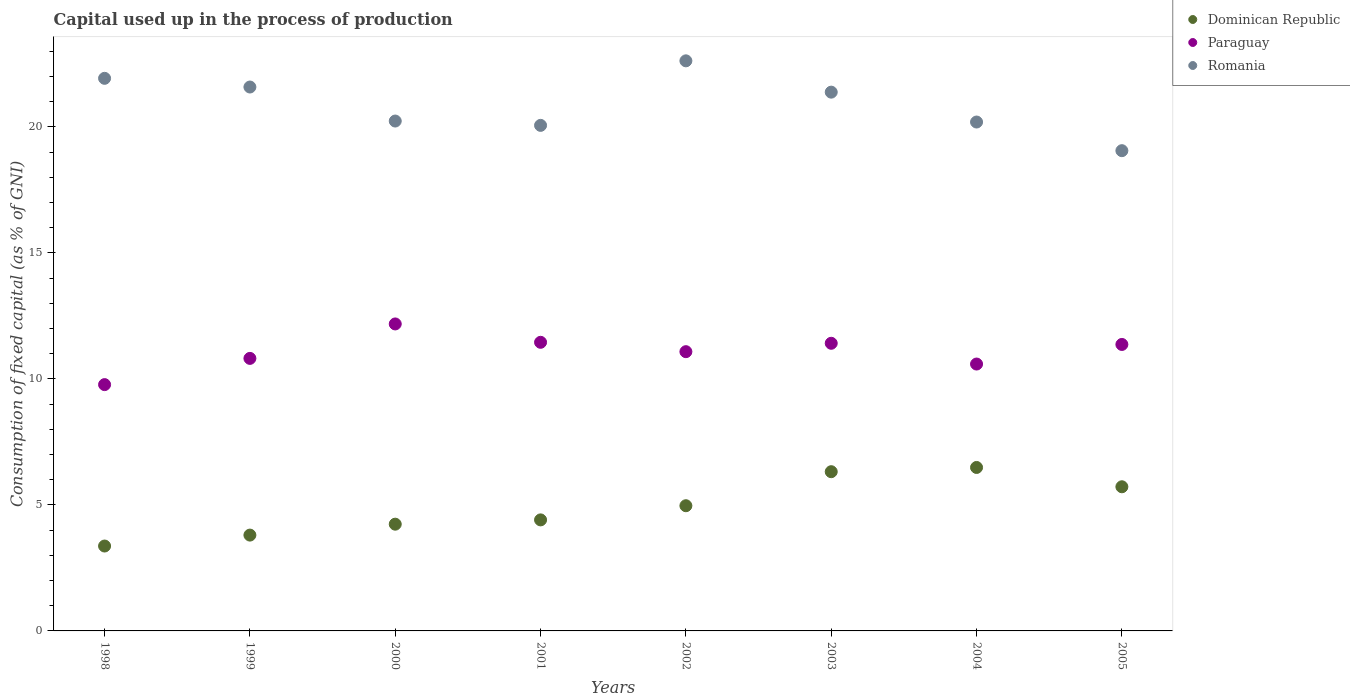How many different coloured dotlines are there?
Your response must be concise. 3. What is the capital used up in the process of production in Romania in 2003?
Your answer should be compact. 21.38. Across all years, what is the maximum capital used up in the process of production in Paraguay?
Offer a very short reply. 12.18. Across all years, what is the minimum capital used up in the process of production in Dominican Republic?
Provide a succinct answer. 3.37. In which year was the capital used up in the process of production in Paraguay maximum?
Make the answer very short. 2000. What is the total capital used up in the process of production in Paraguay in the graph?
Give a very brief answer. 88.68. What is the difference between the capital used up in the process of production in Romania in 2003 and that in 2005?
Offer a terse response. 2.32. What is the difference between the capital used up in the process of production in Romania in 2003 and the capital used up in the process of production in Paraguay in 2005?
Give a very brief answer. 10.01. What is the average capital used up in the process of production in Paraguay per year?
Your answer should be compact. 11.08. In the year 2002, what is the difference between the capital used up in the process of production in Romania and capital used up in the process of production in Dominican Republic?
Your answer should be compact. 17.65. In how many years, is the capital used up in the process of production in Dominican Republic greater than 2 %?
Make the answer very short. 8. What is the ratio of the capital used up in the process of production in Paraguay in 2003 to that in 2005?
Give a very brief answer. 1. Is the difference between the capital used up in the process of production in Romania in 2000 and 2004 greater than the difference between the capital used up in the process of production in Dominican Republic in 2000 and 2004?
Your answer should be compact. Yes. What is the difference between the highest and the second highest capital used up in the process of production in Dominican Republic?
Give a very brief answer. 0.17. What is the difference between the highest and the lowest capital used up in the process of production in Paraguay?
Your answer should be very brief. 2.41. In how many years, is the capital used up in the process of production in Dominican Republic greater than the average capital used up in the process of production in Dominican Republic taken over all years?
Keep it short and to the point. 4. Is the capital used up in the process of production in Dominican Republic strictly greater than the capital used up in the process of production in Romania over the years?
Offer a terse response. No. Is the capital used up in the process of production in Dominican Republic strictly less than the capital used up in the process of production in Romania over the years?
Offer a very short reply. Yes. How many years are there in the graph?
Keep it short and to the point. 8. What is the difference between two consecutive major ticks on the Y-axis?
Your answer should be compact. 5. Are the values on the major ticks of Y-axis written in scientific E-notation?
Keep it short and to the point. No. Does the graph contain grids?
Offer a terse response. No. Where does the legend appear in the graph?
Provide a short and direct response. Top right. What is the title of the graph?
Give a very brief answer. Capital used up in the process of production. What is the label or title of the X-axis?
Provide a short and direct response. Years. What is the label or title of the Y-axis?
Provide a succinct answer. Consumption of fixed capital (as % of GNI). What is the Consumption of fixed capital (as % of GNI) in Dominican Republic in 1998?
Offer a very short reply. 3.37. What is the Consumption of fixed capital (as % of GNI) in Paraguay in 1998?
Provide a succinct answer. 9.77. What is the Consumption of fixed capital (as % of GNI) in Romania in 1998?
Give a very brief answer. 21.93. What is the Consumption of fixed capital (as % of GNI) in Dominican Republic in 1999?
Keep it short and to the point. 3.8. What is the Consumption of fixed capital (as % of GNI) of Paraguay in 1999?
Your response must be concise. 10.81. What is the Consumption of fixed capital (as % of GNI) in Romania in 1999?
Your answer should be compact. 21.58. What is the Consumption of fixed capital (as % of GNI) of Dominican Republic in 2000?
Offer a terse response. 4.24. What is the Consumption of fixed capital (as % of GNI) of Paraguay in 2000?
Ensure brevity in your answer.  12.18. What is the Consumption of fixed capital (as % of GNI) in Romania in 2000?
Your answer should be very brief. 20.23. What is the Consumption of fixed capital (as % of GNI) in Dominican Republic in 2001?
Provide a short and direct response. 4.41. What is the Consumption of fixed capital (as % of GNI) of Paraguay in 2001?
Your answer should be compact. 11.45. What is the Consumption of fixed capital (as % of GNI) in Romania in 2001?
Offer a very short reply. 20.06. What is the Consumption of fixed capital (as % of GNI) of Dominican Republic in 2002?
Make the answer very short. 4.97. What is the Consumption of fixed capital (as % of GNI) of Paraguay in 2002?
Keep it short and to the point. 11.08. What is the Consumption of fixed capital (as % of GNI) in Romania in 2002?
Give a very brief answer. 22.62. What is the Consumption of fixed capital (as % of GNI) in Dominican Republic in 2003?
Your answer should be compact. 6.32. What is the Consumption of fixed capital (as % of GNI) in Paraguay in 2003?
Your answer should be very brief. 11.41. What is the Consumption of fixed capital (as % of GNI) of Romania in 2003?
Your answer should be compact. 21.38. What is the Consumption of fixed capital (as % of GNI) of Dominican Republic in 2004?
Ensure brevity in your answer.  6.49. What is the Consumption of fixed capital (as % of GNI) in Paraguay in 2004?
Your answer should be very brief. 10.59. What is the Consumption of fixed capital (as % of GNI) of Romania in 2004?
Offer a very short reply. 20.19. What is the Consumption of fixed capital (as % of GNI) in Dominican Republic in 2005?
Provide a succinct answer. 5.72. What is the Consumption of fixed capital (as % of GNI) of Paraguay in 2005?
Keep it short and to the point. 11.37. What is the Consumption of fixed capital (as % of GNI) of Romania in 2005?
Your answer should be very brief. 19.06. Across all years, what is the maximum Consumption of fixed capital (as % of GNI) in Dominican Republic?
Provide a succinct answer. 6.49. Across all years, what is the maximum Consumption of fixed capital (as % of GNI) in Paraguay?
Ensure brevity in your answer.  12.18. Across all years, what is the maximum Consumption of fixed capital (as % of GNI) in Romania?
Make the answer very short. 22.62. Across all years, what is the minimum Consumption of fixed capital (as % of GNI) of Dominican Republic?
Your answer should be compact. 3.37. Across all years, what is the minimum Consumption of fixed capital (as % of GNI) in Paraguay?
Offer a very short reply. 9.77. Across all years, what is the minimum Consumption of fixed capital (as % of GNI) in Romania?
Offer a very short reply. 19.06. What is the total Consumption of fixed capital (as % of GNI) in Dominican Republic in the graph?
Provide a short and direct response. 39.31. What is the total Consumption of fixed capital (as % of GNI) in Paraguay in the graph?
Your answer should be very brief. 88.68. What is the total Consumption of fixed capital (as % of GNI) of Romania in the graph?
Your answer should be very brief. 167.06. What is the difference between the Consumption of fixed capital (as % of GNI) in Dominican Republic in 1998 and that in 1999?
Offer a terse response. -0.43. What is the difference between the Consumption of fixed capital (as % of GNI) in Paraguay in 1998 and that in 1999?
Provide a succinct answer. -1.04. What is the difference between the Consumption of fixed capital (as % of GNI) of Romania in 1998 and that in 1999?
Provide a short and direct response. 0.35. What is the difference between the Consumption of fixed capital (as % of GNI) of Dominican Republic in 1998 and that in 2000?
Keep it short and to the point. -0.87. What is the difference between the Consumption of fixed capital (as % of GNI) of Paraguay in 1998 and that in 2000?
Offer a very short reply. -2.41. What is the difference between the Consumption of fixed capital (as % of GNI) in Romania in 1998 and that in 2000?
Provide a short and direct response. 1.7. What is the difference between the Consumption of fixed capital (as % of GNI) in Dominican Republic in 1998 and that in 2001?
Your response must be concise. -1.04. What is the difference between the Consumption of fixed capital (as % of GNI) in Paraguay in 1998 and that in 2001?
Offer a terse response. -1.68. What is the difference between the Consumption of fixed capital (as % of GNI) in Romania in 1998 and that in 2001?
Ensure brevity in your answer.  1.87. What is the difference between the Consumption of fixed capital (as % of GNI) in Dominican Republic in 1998 and that in 2002?
Offer a very short reply. -1.6. What is the difference between the Consumption of fixed capital (as % of GNI) of Paraguay in 1998 and that in 2002?
Offer a terse response. -1.31. What is the difference between the Consumption of fixed capital (as % of GNI) in Romania in 1998 and that in 2002?
Give a very brief answer. -0.69. What is the difference between the Consumption of fixed capital (as % of GNI) of Dominican Republic in 1998 and that in 2003?
Make the answer very short. -2.95. What is the difference between the Consumption of fixed capital (as % of GNI) in Paraguay in 1998 and that in 2003?
Offer a terse response. -1.64. What is the difference between the Consumption of fixed capital (as % of GNI) in Romania in 1998 and that in 2003?
Give a very brief answer. 0.55. What is the difference between the Consumption of fixed capital (as % of GNI) of Dominican Republic in 1998 and that in 2004?
Give a very brief answer. -3.12. What is the difference between the Consumption of fixed capital (as % of GNI) of Paraguay in 1998 and that in 2004?
Your answer should be very brief. -0.82. What is the difference between the Consumption of fixed capital (as % of GNI) in Romania in 1998 and that in 2004?
Your response must be concise. 1.73. What is the difference between the Consumption of fixed capital (as % of GNI) in Dominican Republic in 1998 and that in 2005?
Make the answer very short. -2.35. What is the difference between the Consumption of fixed capital (as % of GNI) in Paraguay in 1998 and that in 2005?
Ensure brevity in your answer.  -1.59. What is the difference between the Consumption of fixed capital (as % of GNI) of Romania in 1998 and that in 2005?
Your answer should be compact. 2.87. What is the difference between the Consumption of fixed capital (as % of GNI) in Dominican Republic in 1999 and that in 2000?
Offer a very short reply. -0.43. What is the difference between the Consumption of fixed capital (as % of GNI) of Paraguay in 1999 and that in 2000?
Keep it short and to the point. -1.37. What is the difference between the Consumption of fixed capital (as % of GNI) of Romania in 1999 and that in 2000?
Ensure brevity in your answer.  1.35. What is the difference between the Consumption of fixed capital (as % of GNI) in Dominican Republic in 1999 and that in 2001?
Your response must be concise. -0.6. What is the difference between the Consumption of fixed capital (as % of GNI) of Paraguay in 1999 and that in 2001?
Offer a very short reply. -0.64. What is the difference between the Consumption of fixed capital (as % of GNI) in Romania in 1999 and that in 2001?
Offer a terse response. 1.52. What is the difference between the Consumption of fixed capital (as % of GNI) of Dominican Republic in 1999 and that in 2002?
Your answer should be very brief. -1.17. What is the difference between the Consumption of fixed capital (as % of GNI) in Paraguay in 1999 and that in 2002?
Provide a short and direct response. -0.27. What is the difference between the Consumption of fixed capital (as % of GNI) of Romania in 1999 and that in 2002?
Provide a short and direct response. -1.04. What is the difference between the Consumption of fixed capital (as % of GNI) of Dominican Republic in 1999 and that in 2003?
Keep it short and to the point. -2.52. What is the difference between the Consumption of fixed capital (as % of GNI) of Paraguay in 1999 and that in 2003?
Your answer should be very brief. -0.6. What is the difference between the Consumption of fixed capital (as % of GNI) in Romania in 1999 and that in 2003?
Make the answer very short. 0.2. What is the difference between the Consumption of fixed capital (as % of GNI) in Dominican Republic in 1999 and that in 2004?
Your response must be concise. -2.68. What is the difference between the Consumption of fixed capital (as % of GNI) in Paraguay in 1999 and that in 2004?
Offer a very short reply. 0.22. What is the difference between the Consumption of fixed capital (as % of GNI) of Romania in 1999 and that in 2004?
Ensure brevity in your answer.  1.39. What is the difference between the Consumption of fixed capital (as % of GNI) in Dominican Republic in 1999 and that in 2005?
Your answer should be very brief. -1.92. What is the difference between the Consumption of fixed capital (as % of GNI) in Paraguay in 1999 and that in 2005?
Provide a short and direct response. -0.55. What is the difference between the Consumption of fixed capital (as % of GNI) in Romania in 1999 and that in 2005?
Your answer should be very brief. 2.53. What is the difference between the Consumption of fixed capital (as % of GNI) of Dominican Republic in 2000 and that in 2001?
Provide a short and direct response. -0.17. What is the difference between the Consumption of fixed capital (as % of GNI) of Paraguay in 2000 and that in 2001?
Your answer should be very brief. 0.73. What is the difference between the Consumption of fixed capital (as % of GNI) of Romania in 2000 and that in 2001?
Provide a succinct answer. 0.17. What is the difference between the Consumption of fixed capital (as % of GNI) in Dominican Republic in 2000 and that in 2002?
Keep it short and to the point. -0.73. What is the difference between the Consumption of fixed capital (as % of GNI) in Paraguay in 2000 and that in 2002?
Your answer should be very brief. 1.1. What is the difference between the Consumption of fixed capital (as % of GNI) of Romania in 2000 and that in 2002?
Offer a very short reply. -2.39. What is the difference between the Consumption of fixed capital (as % of GNI) in Dominican Republic in 2000 and that in 2003?
Your response must be concise. -2.08. What is the difference between the Consumption of fixed capital (as % of GNI) of Paraguay in 2000 and that in 2003?
Your response must be concise. 0.77. What is the difference between the Consumption of fixed capital (as % of GNI) of Romania in 2000 and that in 2003?
Your response must be concise. -1.15. What is the difference between the Consumption of fixed capital (as % of GNI) in Dominican Republic in 2000 and that in 2004?
Ensure brevity in your answer.  -2.25. What is the difference between the Consumption of fixed capital (as % of GNI) in Paraguay in 2000 and that in 2004?
Your answer should be compact. 1.59. What is the difference between the Consumption of fixed capital (as % of GNI) of Romania in 2000 and that in 2004?
Provide a succinct answer. 0.04. What is the difference between the Consumption of fixed capital (as % of GNI) of Dominican Republic in 2000 and that in 2005?
Your response must be concise. -1.48. What is the difference between the Consumption of fixed capital (as % of GNI) of Paraguay in 2000 and that in 2005?
Offer a terse response. 0.81. What is the difference between the Consumption of fixed capital (as % of GNI) in Romania in 2000 and that in 2005?
Offer a very short reply. 1.18. What is the difference between the Consumption of fixed capital (as % of GNI) in Dominican Republic in 2001 and that in 2002?
Offer a very short reply. -0.56. What is the difference between the Consumption of fixed capital (as % of GNI) in Paraguay in 2001 and that in 2002?
Give a very brief answer. 0.37. What is the difference between the Consumption of fixed capital (as % of GNI) of Romania in 2001 and that in 2002?
Your answer should be compact. -2.56. What is the difference between the Consumption of fixed capital (as % of GNI) in Dominican Republic in 2001 and that in 2003?
Make the answer very short. -1.91. What is the difference between the Consumption of fixed capital (as % of GNI) in Paraguay in 2001 and that in 2003?
Offer a very short reply. 0.04. What is the difference between the Consumption of fixed capital (as % of GNI) in Romania in 2001 and that in 2003?
Give a very brief answer. -1.32. What is the difference between the Consumption of fixed capital (as % of GNI) in Dominican Republic in 2001 and that in 2004?
Offer a very short reply. -2.08. What is the difference between the Consumption of fixed capital (as % of GNI) of Paraguay in 2001 and that in 2004?
Make the answer very short. 0.86. What is the difference between the Consumption of fixed capital (as % of GNI) of Romania in 2001 and that in 2004?
Your answer should be compact. -0.13. What is the difference between the Consumption of fixed capital (as % of GNI) of Dominican Republic in 2001 and that in 2005?
Give a very brief answer. -1.31. What is the difference between the Consumption of fixed capital (as % of GNI) of Paraguay in 2001 and that in 2005?
Keep it short and to the point. 0.09. What is the difference between the Consumption of fixed capital (as % of GNI) of Romania in 2001 and that in 2005?
Your response must be concise. 1. What is the difference between the Consumption of fixed capital (as % of GNI) of Dominican Republic in 2002 and that in 2003?
Ensure brevity in your answer.  -1.35. What is the difference between the Consumption of fixed capital (as % of GNI) of Paraguay in 2002 and that in 2003?
Keep it short and to the point. -0.33. What is the difference between the Consumption of fixed capital (as % of GNI) in Romania in 2002 and that in 2003?
Keep it short and to the point. 1.24. What is the difference between the Consumption of fixed capital (as % of GNI) in Dominican Republic in 2002 and that in 2004?
Keep it short and to the point. -1.52. What is the difference between the Consumption of fixed capital (as % of GNI) in Paraguay in 2002 and that in 2004?
Your answer should be compact. 0.49. What is the difference between the Consumption of fixed capital (as % of GNI) in Romania in 2002 and that in 2004?
Give a very brief answer. 2.43. What is the difference between the Consumption of fixed capital (as % of GNI) in Dominican Republic in 2002 and that in 2005?
Offer a terse response. -0.75. What is the difference between the Consumption of fixed capital (as % of GNI) in Paraguay in 2002 and that in 2005?
Give a very brief answer. -0.29. What is the difference between the Consumption of fixed capital (as % of GNI) of Romania in 2002 and that in 2005?
Keep it short and to the point. 3.56. What is the difference between the Consumption of fixed capital (as % of GNI) in Dominican Republic in 2003 and that in 2004?
Make the answer very short. -0.17. What is the difference between the Consumption of fixed capital (as % of GNI) in Paraguay in 2003 and that in 2004?
Offer a terse response. 0.82. What is the difference between the Consumption of fixed capital (as % of GNI) in Romania in 2003 and that in 2004?
Make the answer very short. 1.19. What is the difference between the Consumption of fixed capital (as % of GNI) in Dominican Republic in 2003 and that in 2005?
Your answer should be compact. 0.6. What is the difference between the Consumption of fixed capital (as % of GNI) of Paraguay in 2003 and that in 2005?
Ensure brevity in your answer.  0.05. What is the difference between the Consumption of fixed capital (as % of GNI) in Romania in 2003 and that in 2005?
Your answer should be very brief. 2.32. What is the difference between the Consumption of fixed capital (as % of GNI) of Dominican Republic in 2004 and that in 2005?
Your answer should be compact. 0.77. What is the difference between the Consumption of fixed capital (as % of GNI) in Paraguay in 2004 and that in 2005?
Make the answer very short. -0.78. What is the difference between the Consumption of fixed capital (as % of GNI) in Romania in 2004 and that in 2005?
Make the answer very short. 1.14. What is the difference between the Consumption of fixed capital (as % of GNI) of Dominican Republic in 1998 and the Consumption of fixed capital (as % of GNI) of Paraguay in 1999?
Give a very brief answer. -7.45. What is the difference between the Consumption of fixed capital (as % of GNI) in Dominican Republic in 1998 and the Consumption of fixed capital (as % of GNI) in Romania in 1999?
Your answer should be compact. -18.21. What is the difference between the Consumption of fixed capital (as % of GNI) of Paraguay in 1998 and the Consumption of fixed capital (as % of GNI) of Romania in 1999?
Ensure brevity in your answer.  -11.81. What is the difference between the Consumption of fixed capital (as % of GNI) in Dominican Republic in 1998 and the Consumption of fixed capital (as % of GNI) in Paraguay in 2000?
Give a very brief answer. -8.81. What is the difference between the Consumption of fixed capital (as % of GNI) of Dominican Republic in 1998 and the Consumption of fixed capital (as % of GNI) of Romania in 2000?
Make the answer very short. -16.86. What is the difference between the Consumption of fixed capital (as % of GNI) in Paraguay in 1998 and the Consumption of fixed capital (as % of GNI) in Romania in 2000?
Provide a short and direct response. -10.46. What is the difference between the Consumption of fixed capital (as % of GNI) of Dominican Republic in 1998 and the Consumption of fixed capital (as % of GNI) of Paraguay in 2001?
Offer a very short reply. -8.08. What is the difference between the Consumption of fixed capital (as % of GNI) of Dominican Republic in 1998 and the Consumption of fixed capital (as % of GNI) of Romania in 2001?
Make the answer very short. -16.69. What is the difference between the Consumption of fixed capital (as % of GNI) of Paraguay in 1998 and the Consumption of fixed capital (as % of GNI) of Romania in 2001?
Provide a short and direct response. -10.29. What is the difference between the Consumption of fixed capital (as % of GNI) in Dominican Republic in 1998 and the Consumption of fixed capital (as % of GNI) in Paraguay in 2002?
Provide a succinct answer. -7.71. What is the difference between the Consumption of fixed capital (as % of GNI) of Dominican Republic in 1998 and the Consumption of fixed capital (as % of GNI) of Romania in 2002?
Your answer should be very brief. -19.25. What is the difference between the Consumption of fixed capital (as % of GNI) in Paraguay in 1998 and the Consumption of fixed capital (as % of GNI) in Romania in 2002?
Your response must be concise. -12.85. What is the difference between the Consumption of fixed capital (as % of GNI) in Dominican Republic in 1998 and the Consumption of fixed capital (as % of GNI) in Paraguay in 2003?
Your response must be concise. -8.05. What is the difference between the Consumption of fixed capital (as % of GNI) of Dominican Republic in 1998 and the Consumption of fixed capital (as % of GNI) of Romania in 2003?
Your response must be concise. -18.01. What is the difference between the Consumption of fixed capital (as % of GNI) of Paraguay in 1998 and the Consumption of fixed capital (as % of GNI) of Romania in 2003?
Your response must be concise. -11.61. What is the difference between the Consumption of fixed capital (as % of GNI) in Dominican Republic in 1998 and the Consumption of fixed capital (as % of GNI) in Paraguay in 2004?
Make the answer very short. -7.22. What is the difference between the Consumption of fixed capital (as % of GNI) of Dominican Republic in 1998 and the Consumption of fixed capital (as % of GNI) of Romania in 2004?
Ensure brevity in your answer.  -16.83. What is the difference between the Consumption of fixed capital (as % of GNI) of Paraguay in 1998 and the Consumption of fixed capital (as % of GNI) of Romania in 2004?
Make the answer very short. -10.42. What is the difference between the Consumption of fixed capital (as % of GNI) in Dominican Republic in 1998 and the Consumption of fixed capital (as % of GNI) in Paraguay in 2005?
Make the answer very short. -8. What is the difference between the Consumption of fixed capital (as % of GNI) in Dominican Republic in 1998 and the Consumption of fixed capital (as % of GNI) in Romania in 2005?
Provide a succinct answer. -15.69. What is the difference between the Consumption of fixed capital (as % of GNI) of Paraguay in 1998 and the Consumption of fixed capital (as % of GNI) of Romania in 2005?
Your answer should be compact. -9.28. What is the difference between the Consumption of fixed capital (as % of GNI) of Dominican Republic in 1999 and the Consumption of fixed capital (as % of GNI) of Paraguay in 2000?
Provide a succinct answer. -8.38. What is the difference between the Consumption of fixed capital (as % of GNI) of Dominican Republic in 1999 and the Consumption of fixed capital (as % of GNI) of Romania in 2000?
Make the answer very short. -16.43. What is the difference between the Consumption of fixed capital (as % of GNI) in Paraguay in 1999 and the Consumption of fixed capital (as % of GNI) in Romania in 2000?
Keep it short and to the point. -9.42. What is the difference between the Consumption of fixed capital (as % of GNI) in Dominican Republic in 1999 and the Consumption of fixed capital (as % of GNI) in Paraguay in 2001?
Provide a short and direct response. -7.65. What is the difference between the Consumption of fixed capital (as % of GNI) of Dominican Republic in 1999 and the Consumption of fixed capital (as % of GNI) of Romania in 2001?
Make the answer very short. -16.26. What is the difference between the Consumption of fixed capital (as % of GNI) in Paraguay in 1999 and the Consumption of fixed capital (as % of GNI) in Romania in 2001?
Offer a terse response. -9.25. What is the difference between the Consumption of fixed capital (as % of GNI) in Dominican Republic in 1999 and the Consumption of fixed capital (as % of GNI) in Paraguay in 2002?
Your answer should be very brief. -7.28. What is the difference between the Consumption of fixed capital (as % of GNI) in Dominican Republic in 1999 and the Consumption of fixed capital (as % of GNI) in Romania in 2002?
Make the answer very short. -18.82. What is the difference between the Consumption of fixed capital (as % of GNI) in Paraguay in 1999 and the Consumption of fixed capital (as % of GNI) in Romania in 2002?
Provide a succinct answer. -11.81. What is the difference between the Consumption of fixed capital (as % of GNI) in Dominican Republic in 1999 and the Consumption of fixed capital (as % of GNI) in Paraguay in 2003?
Your response must be concise. -7.61. What is the difference between the Consumption of fixed capital (as % of GNI) of Dominican Republic in 1999 and the Consumption of fixed capital (as % of GNI) of Romania in 2003?
Keep it short and to the point. -17.58. What is the difference between the Consumption of fixed capital (as % of GNI) in Paraguay in 1999 and the Consumption of fixed capital (as % of GNI) in Romania in 2003?
Offer a terse response. -10.57. What is the difference between the Consumption of fixed capital (as % of GNI) in Dominican Republic in 1999 and the Consumption of fixed capital (as % of GNI) in Paraguay in 2004?
Your answer should be compact. -6.79. What is the difference between the Consumption of fixed capital (as % of GNI) of Dominican Republic in 1999 and the Consumption of fixed capital (as % of GNI) of Romania in 2004?
Offer a terse response. -16.39. What is the difference between the Consumption of fixed capital (as % of GNI) of Paraguay in 1999 and the Consumption of fixed capital (as % of GNI) of Romania in 2004?
Ensure brevity in your answer.  -9.38. What is the difference between the Consumption of fixed capital (as % of GNI) in Dominican Republic in 1999 and the Consumption of fixed capital (as % of GNI) in Paraguay in 2005?
Your response must be concise. -7.57. What is the difference between the Consumption of fixed capital (as % of GNI) of Dominican Republic in 1999 and the Consumption of fixed capital (as % of GNI) of Romania in 2005?
Offer a terse response. -15.26. What is the difference between the Consumption of fixed capital (as % of GNI) of Paraguay in 1999 and the Consumption of fixed capital (as % of GNI) of Romania in 2005?
Your response must be concise. -8.24. What is the difference between the Consumption of fixed capital (as % of GNI) in Dominican Republic in 2000 and the Consumption of fixed capital (as % of GNI) in Paraguay in 2001?
Your answer should be very brief. -7.22. What is the difference between the Consumption of fixed capital (as % of GNI) in Dominican Republic in 2000 and the Consumption of fixed capital (as % of GNI) in Romania in 2001?
Provide a short and direct response. -15.83. What is the difference between the Consumption of fixed capital (as % of GNI) in Paraguay in 2000 and the Consumption of fixed capital (as % of GNI) in Romania in 2001?
Your response must be concise. -7.88. What is the difference between the Consumption of fixed capital (as % of GNI) of Dominican Republic in 2000 and the Consumption of fixed capital (as % of GNI) of Paraguay in 2002?
Keep it short and to the point. -6.85. What is the difference between the Consumption of fixed capital (as % of GNI) in Dominican Republic in 2000 and the Consumption of fixed capital (as % of GNI) in Romania in 2002?
Keep it short and to the point. -18.39. What is the difference between the Consumption of fixed capital (as % of GNI) of Paraguay in 2000 and the Consumption of fixed capital (as % of GNI) of Romania in 2002?
Your answer should be compact. -10.44. What is the difference between the Consumption of fixed capital (as % of GNI) in Dominican Republic in 2000 and the Consumption of fixed capital (as % of GNI) in Paraguay in 2003?
Ensure brevity in your answer.  -7.18. What is the difference between the Consumption of fixed capital (as % of GNI) in Dominican Republic in 2000 and the Consumption of fixed capital (as % of GNI) in Romania in 2003?
Make the answer very short. -17.14. What is the difference between the Consumption of fixed capital (as % of GNI) in Paraguay in 2000 and the Consumption of fixed capital (as % of GNI) in Romania in 2003?
Offer a very short reply. -9.2. What is the difference between the Consumption of fixed capital (as % of GNI) in Dominican Republic in 2000 and the Consumption of fixed capital (as % of GNI) in Paraguay in 2004?
Provide a succinct answer. -6.35. What is the difference between the Consumption of fixed capital (as % of GNI) of Dominican Republic in 2000 and the Consumption of fixed capital (as % of GNI) of Romania in 2004?
Your answer should be very brief. -15.96. What is the difference between the Consumption of fixed capital (as % of GNI) of Paraguay in 2000 and the Consumption of fixed capital (as % of GNI) of Romania in 2004?
Provide a short and direct response. -8.01. What is the difference between the Consumption of fixed capital (as % of GNI) of Dominican Republic in 2000 and the Consumption of fixed capital (as % of GNI) of Paraguay in 2005?
Ensure brevity in your answer.  -7.13. What is the difference between the Consumption of fixed capital (as % of GNI) in Dominican Republic in 2000 and the Consumption of fixed capital (as % of GNI) in Romania in 2005?
Your answer should be compact. -14.82. What is the difference between the Consumption of fixed capital (as % of GNI) of Paraguay in 2000 and the Consumption of fixed capital (as % of GNI) of Romania in 2005?
Your response must be concise. -6.88. What is the difference between the Consumption of fixed capital (as % of GNI) in Dominican Republic in 2001 and the Consumption of fixed capital (as % of GNI) in Paraguay in 2002?
Your answer should be very brief. -6.68. What is the difference between the Consumption of fixed capital (as % of GNI) of Dominican Republic in 2001 and the Consumption of fixed capital (as % of GNI) of Romania in 2002?
Offer a terse response. -18.22. What is the difference between the Consumption of fixed capital (as % of GNI) in Paraguay in 2001 and the Consumption of fixed capital (as % of GNI) in Romania in 2002?
Ensure brevity in your answer.  -11.17. What is the difference between the Consumption of fixed capital (as % of GNI) in Dominican Republic in 2001 and the Consumption of fixed capital (as % of GNI) in Paraguay in 2003?
Make the answer very short. -7.01. What is the difference between the Consumption of fixed capital (as % of GNI) in Dominican Republic in 2001 and the Consumption of fixed capital (as % of GNI) in Romania in 2003?
Offer a terse response. -16.97. What is the difference between the Consumption of fixed capital (as % of GNI) of Paraguay in 2001 and the Consumption of fixed capital (as % of GNI) of Romania in 2003?
Keep it short and to the point. -9.93. What is the difference between the Consumption of fixed capital (as % of GNI) of Dominican Republic in 2001 and the Consumption of fixed capital (as % of GNI) of Paraguay in 2004?
Ensure brevity in your answer.  -6.18. What is the difference between the Consumption of fixed capital (as % of GNI) in Dominican Republic in 2001 and the Consumption of fixed capital (as % of GNI) in Romania in 2004?
Provide a succinct answer. -15.79. What is the difference between the Consumption of fixed capital (as % of GNI) in Paraguay in 2001 and the Consumption of fixed capital (as % of GNI) in Romania in 2004?
Your answer should be compact. -8.74. What is the difference between the Consumption of fixed capital (as % of GNI) of Dominican Republic in 2001 and the Consumption of fixed capital (as % of GNI) of Paraguay in 2005?
Offer a terse response. -6.96. What is the difference between the Consumption of fixed capital (as % of GNI) in Dominican Republic in 2001 and the Consumption of fixed capital (as % of GNI) in Romania in 2005?
Your response must be concise. -14.65. What is the difference between the Consumption of fixed capital (as % of GNI) of Paraguay in 2001 and the Consumption of fixed capital (as % of GNI) of Romania in 2005?
Make the answer very short. -7.6. What is the difference between the Consumption of fixed capital (as % of GNI) in Dominican Republic in 2002 and the Consumption of fixed capital (as % of GNI) in Paraguay in 2003?
Provide a short and direct response. -6.45. What is the difference between the Consumption of fixed capital (as % of GNI) of Dominican Republic in 2002 and the Consumption of fixed capital (as % of GNI) of Romania in 2003?
Provide a succinct answer. -16.41. What is the difference between the Consumption of fixed capital (as % of GNI) of Paraguay in 2002 and the Consumption of fixed capital (as % of GNI) of Romania in 2003?
Keep it short and to the point. -10.3. What is the difference between the Consumption of fixed capital (as % of GNI) in Dominican Republic in 2002 and the Consumption of fixed capital (as % of GNI) in Paraguay in 2004?
Your answer should be compact. -5.62. What is the difference between the Consumption of fixed capital (as % of GNI) in Dominican Republic in 2002 and the Consumption of fixed capital (as % of GNI) in Romania in 2004?
Your answer should be very brief. -15.23. What is the difference between the Consumption of fixed capital (as % of GNI) in Paraguay in 2002 and the Consumption of fixed capital (as % of GNI) in Romania in 2004?
Your answer should be very brief. -9.11. What is the difference between the Consumption of fixed capital (as % of GNI) of Dominican Republic in 2002 and the Consumption of fixed capital (as % of GNI) of Paraguay in 2005?
Provide a short and direct response. -6.4. What is the difference between the Consumption of fixed capital (as % of GNI) of Dominican Republic in 2002 and the Consumption of fixed capital (as % of GNI) of Romania in 2005?
Your answer should be compact. -14.09. What is the difference between the Consumption of fixed capital (as % of GNI) in Paraguay in 2002 and the Consumption of fixed capital (as % of GNI) in Romania in 2005?
Give a very brief answer. -7.98. What is the difference between the Consumption of fixed capital (as % of GNI) in Dominican Republic in 2003 and the Consumption of fixed capital (as % of GNI) in Paraguay in 2004?
Ensure brevity in your answer.  -4.27. What is the difference between the Consumption of fixed capital (as % of GNI) of Dominican Republic in 2003 and the Consumption of fixed capital (as % of GNI) of Romania in 2004?
Your answer should be compact. -13.88. What is the difference between the Consumption of fixed capital (as % of GNI) of Paraguay in 2003 and the Consumption of fixed capital (as % of GNI) of Romania in 2004?
Your answer should be compact. -8.78. What is the difference between the Consumption of fixed capital (as % of GNI) of Dominican Republic in 2003 and the Consumption of fixed capital (as % of GNI) of Paraguay in 2005?
Provide a short and direct response. -5.05. What is the difference between the Consumption of fixed capital (as % of GNI) of Dominican Republic in 2003 and the Consumption of fixed capital (as % of GNI) of Romania in 2005?
Keep it short and to the point. -12.74. What is the difference between the Consumption of fixed capital (as % of GNI) of Paraguay in 2003 and the Consumption of fixed capital (as % of GNI) of Romania in 2005?
Provide a succinct answer. -7.64. What is the difference between the Consumption of fixed capital (as % of GNI) in Dominican Republic in 2004 and the Consumption of fixed capital (as % of GNI) in Paraguay in 2005?
Provide a succinct answer. -4.88. What is the difference between the Consumption of fixed capital (as % of GNI) of Dominican Republic in 2004 and the Consumption of fixed capital (as % of GNI) of Romania in 2005?
Keep it short and to the point. -12.57. What is the difference between the Consumption of fixed capital (as % of GNI) of Paraguay in 2004 and the Consumption of fixed capital (as % of GNI) of Romania in 2005?
Offer a very short reply. -8.47. What is the average Consumption of fixed capital (as % of GNI) in Dominican Republic per year?
Your answer should be compact. 4.91. What is the average Consumption of fixed capital (as % of GNI) of Paraguay per year?
Your answer should be very brief. 11.08. What is the average Consumption of fixed capital (as % of GNI) of Romania per year?
Your answer should be compact. 20.88. In the year 1998, what is the difference between the Consumption of fixed capital (as % of GNI) in Dominican Republic and Consumption of fixed capital (as % of GNI) in Paraguay?
Your answer should be compact. -6.41. In the year 1998, what is the difference between the Consumption of fixed capital (as % of GNI) of Dominican Republic and Consumption of fixed capital (as % of GNI) of Romania?
Offer a very short reply. -18.56. In the year 1998, what is the difference between the Consumption of fixed capital (as % of GNI) in Paraguay and Consumption of fixed capital (as % of GNI) in Romania?
Your answer should be compact. -12.15. In the year 1999, what is the difference between the Consumption of fixed capital (as % of GNI) of Dominican Republic and Consumption of fixed capital (as % of GNI) of Paraguay?
Make the answer very short. -7.01. In the year 1999, what is the difference between the Consumption of fixed capital (as % of GNI) in Dominican Republic and Consumption of fixed capital (as % of GNI) in Romania?
Your answer should be compact. -17.78. In the year 1999, what is the difference between the Consumption of fixed capital (as % of GNI) of Paraguay and Consumption of fixed capital (as % of GNI) of Romania?
Offer a very short reply. -10.77. In the year 2000, what is the difference between the Consumption of fixed capital (as % of GNI) of Dominican Republic and Consumption of fixed capital (as % of GNI) of Paraguay?
Give a very brief answer. -7.95. In the year 2000, what is the difference between the Consumption of fixed capital (as % of GNI) in Dominican Republic and Consumption of fixed capital (as % of GNI) in Romania?
Provide a succinct answer. -16. In the year 2000, what is the difference between the Consumption of fixed capital (as % of GNI) in Paraguay and Consumption of fixed capital (as % of GNI) in Romania?
Your answer should be very brief. -8.05. In the year 2001, what is the difference between the Consumption of fixed capital (as % of GNI) of Dominican Republic and Consumption of fixed capital (as % of GNI) of Paraguay?
Your answer should be compact. -7.05. In the year 2001, what is the difference between the Consumption of fixed capital (as % of GNI) of Dominican Republic and Consumption of fixed capital (as % of GNI) of Romania?
Make the answer very short. -15.66. In the year 2001, what is the difference between the Consumption of fixed capital (as % of GNI) of Paraguay and Consumption of fixed capital (as % of GNI) of Romania?
Provide a succinct answer. -8.61. In the year 2002, what is the difference between the Consumption of fixed capital (as % of GNI) of Dominican Republic and Consumption of fixed capital (as % of GNI) of Paraguay?
Keep it short and to the point. -6.11. In the year 2002, what is the difference between the Consumption of fixed capital (as % of GNI) of Dominican Republic and Consumption of fixed capital (as % of GNI) of Romania?
Your answer should be compact. -17.65. In the year 2002, what is the difference between the Consumption of fixed capital (as % of GNI) of Paraguay and Consumption of fixed capital (as % of GNI) of Romania?
Offer a very short reply. -11.54. In the year 2003, what is the difference between the Consumption of fixed capital (as % of GNI) in Dominican Republic and Consumption of fixed capital (as % of GNI) in Paraguay?
Offer a very short reply. -5.1. In the year 2003, what is the difference between the Consumption of fixed capital (as % of GNI) of Dominican Republic and Consumption of fixed capital (as % of GNI) of Romania?
Offer a terse response. -15.06. In the year 2003, what is the difference between the Consumption of fixed capital (as % of GNI) in Paraguay and Consumption of fixed capital (as % of GNI) in Romania?
Give a very brief answer. -9.97. In the year 2004, what is the difference between the Consumption of fixed capital (as % of GNI) of Dominican Republic and Consumption of fixed capital (as % of GNI) of Paraguay?
Offer a very short reply. -4.1. In the year 2004, what is the difference between the Consumption of fixed capital (as % of GNI) in Dominican Republic and Consumption of fixed capital (as % of GNI) in Romania?
Give a very brief answer. -13.71. In the year 2004, what is the difference between the Consumption of fixed capital (as % of GNI) in Paraguay and Consumption of fixed capital (as % of GNI) in Romania?
Ensure brevity in your answer.  -9.6. In the year 2005, what is the difference between the Consumption of fixed capital (as % of GNI) of Dominican Republic and Consumption of fixed capital (as % of GNI) of Paraguay?
Provide a short and direct response. -5.65. In the year 2005, what is the difference between the Consumption of fixed capital (as % of GNI) of Dominican Republic and Consumption of fixed capital (as % of GNI) of Romania?
Your answer should be compact. -13.34. In the year 2005, what is the difference between the Consumption of fixed capital (as % of GNI) in Paraguay and Consumption of fixed capital (as % of GNI) in Romania?
Your response must be concise. -7.69. What is the ratio of the Consumption of fixed capital (as % of GNI) of Dominican Republic in 1998 to that in 1999?
Offer a terse response. 0.89. What is the ratio of the Consumption of fixed capital (as % of GNI) in Paraguay in 1998 to that in 1999?
Ensure brevity in your answer.  0.9. What is the ratio of the Consumption of fixed capital (as % of GNI) of Romania in 1998 to that in 1999?
Provide a succinct answer. 1.02. What is the ratio of the Consumption of fixed capital (as % of GNI) in Dominican Republic in 1998 to that in 2000?
Ensure brevity in your answer.  0.8. What is the ratio of the Consumption of fixed capital (as % of GNI) in Paraguay in 1998 to that in 2000?
Your answer should be very brief. 0.8. What is the ratio of the Consumption of fixed capital (as % of GNI) of Romania in 1998 to that in 2000?
Offer a very short reply. 1.08. What is the ratio of the Consumption of fixed capital (as % of GNI) in Dominican Republic in 1998 to that in 2001?
Your answer should be very brief. 0.76. What is the ratio of the Consumption of fixed capital (as % of GNI) in Paraguay in 1998 to that in 2001?
Provide a succinct answer. 0.85. What is the ratio of the Consumption of fixed capital (as % of GNI) in Romania in 1998 to that in 2001?
Offer a very short reply. 1.09. What is the ratio of the Consumption of fixed capital (as % of GNI) in Dominican Republic in 1998 to that in 2002?
Make the answer very short. 0.68. What is the ratio of the Consumption of fixed capital (as % of GNI) of Paraguay in 1998 to that in 2002?
Your answer should be compact. 0.88. What is the ratio of the Consumption of fixed capital (as % of GNI) of Romania in 1998 to that in 2002?
Make the answer very short. 0.97. What is the ratio of the Consumption of fixed capital (as % of GNI) of Dominican Republic in 1998 to that in 2003?
Give a very brief answer. 0.53. What is the ratio of the Consumption of fixed capital (as % of GNI) in Paraguay in 1998 to that in 2003?
Your answer should be very brief. 0.86. What is the ratio of the Consumption of fixed capital (as % of GNI) of Romania in 1998 to that in 2003?
Your answer should be very brief. 1.03. What is the ratio of the Consumption of fixed capital (as % of GNI) of Dominican Republic in 1998 to that in 2004?
Provide a short and direct response. 0.52. What is the ratio of the Consumption of fixed capital (as % of GNI) of Paraguay in 1998 to that in 2004?
Make the answer very short. 0.92. What is the ratio of the Consumption of fixed capital (as % of GNI) in Romania in 1998 to that in 2004?
Make the answer very short. 1.09. What is the ratio of the Consumption of fixed capital (as % of GNI) of Dominican Republic in 1998 to that in 2005?
Your answer should be very brief. 0.59. What is the ratio of the Consumption of fixed capital (as % of GNI) in Paraguay in 1998 to that in 2005?
Your answer should be very brief. 0.86. What is the ratio of the Consumption of fixed capital (as % of GNI) in Romania in 1998 to that in 2005?
Your answer should be compact. 1.15. What is the ratio of the Consumption of fixed capital (as % of GNI) of Dominican Republic in 1999 to that in 2000?
Provide a succinct answer. 0.9. What is the ratio of the Consumption of fixed capital (as % of GNI) in Paraguay in 1999 to that in 2000?
Make the answer very short. 0.89. What is the ratio of the Consumption of fixed capital (as % of GNI) in Romania in 1999 to that in 2000?
Offer a very short reply. 1.07. What is the ratio of the Consumption of fixed capital (as % of GNI) of Dominican Republic in 1999 to that in 2001?
Your answer should be compact. 0.86. What is the ratio of the Consumption of fixed capital (as % of GNI) in Paraguay in 1999 to that in 2001?
Provide a succinct answer. 0.94. What is the ratio of the Consumption of fixed capital (as % of GNI) of Romania in 1999 to that in 2001?
Provide a short and direct response. 1.08. What is the ratio of the Consumption of fixed capital (as % of GNI) in Dominican Republic in 1999 to that in 2002?
Offer a very short reply. 0.77. What is the ratio of the Consumption of fixed capital (as % of GNI) of Paraguay in 1999 to that in 2002?
Ensure brevity in your answer.  0.98. What is the ratio of the Consumption of fixed capital (as % of GNI) of Romania in 1999 to that in 2002?
Your answer should be very brief. 0.95. What is the ratio of the Consumption of fixed capital (as % of GNI) of Dominican Republic in 1999 to that in 2003?
Provide a succinct answer. 0.6. What is the ratio of the Consumption of fixed capital (as % of GNI) of Paraguay in 1999 to that in 2003?
Give a very brief answer. 0.95. What is the ratio of the Consumption of fixed capital (as % of GNI) in Romania in 1999 to that in 2003?
Your response must be concise. 1.01. What is the ratio of the Consumption of fixed capital (as % of GNI) in Dominican Republic in 1999 to that in 2004?
Provide a succinct answer. 0.59. What is the ratio of the Consumption of fixed capital (as % of GNI) in Paraguay in 1999 to that in 2004?
Your answer should be very brief. 1.02. What is the ratio of the Consumption of fixed capital (as % of GNI) of Romania in 1999 to that in 2004?
Give a very brief answer. 1.07. What is the ratio of the Consumption of fixed capital (as % of GNI) in Dominican Republic in 1999 to that in 2005?
Offer a terse response. 0.66. What is the ratio of the Consumption of fixed capital (as % of GNI) in Paraguay in 1999 to that in 2005?
Keep it short and to the point. 0.95. What is the ratio of the Consumption of fixed capital (as % of GNI) of Romania in 1999 to that in 2005?
Your answer should be very brief. 1.13. What is the ratio of the Consumption of fixed capital (as % of GNI) in Dominican Republic in 2000 to that in 2001?
Provide a succinct answer. 0.96. What is the ratio of the Consumption of fixed capital (as % of GNI) of Paraguay in 2000 to that in 2001?
Your answer should be compact. 1.06. What is the ratio of the Consumption of fixed capital (as % of GNI) of Romania in 2000 to that in 2001?
Your answer should be compact. 1.01. What is the ratio of the Consumption of fixed capital (as % of GNI) of Dominican Republic in 2000 to that in 2002?
Provide a short and direct response. 0.85. What is the ratio of the Consumption of fixed capital (as % of GNI) in Paraguay in 2000 to that in 2002?
Ensure brevity in your answer.  1.1. What is the ratio of the Consumption of fixed capital (as % of GNI) in Romania in 2000 to that in 2002?
Make the answer very short. 0.89. What is the ratio of the Consumption of fixed capital (as % of GNI) in Dominican Republic in 2000 to that in 2003?
Make the answer very short. 0.67. What is the ratio of the Consumption of fixed capital (as % of GNI) in Paraguay in 2000 to that in 2003?
Ensure brevity in your answer.  1.07. What is the ratio of the Consumption of fixed capital (as % of GNI) in Romania in 2000 to that in 2003?
Provide a short and direct response. 0.95. What is the ratio of the Consumption of fixed capital (as % of GNI) in Dominican Republic in 2000 to that in 2004?
Provide a short and direct response. 0.65. What is the ratio of the Consumption of fixed capital (as % of GNI) of Paraguay in 2000 to that in 2004?
Your answer should be very brief. 1.15. What is the ratio of the Consumption of fixed capital (as % of GNI) in Dominican Republic in 2000 to that in 2005?
Provide a short and direct response. 0.74. What is the ratio of the Consumption of fixed capital (as % of GNI) in Paraguay in 2000 to that in 2005?
Your answer should be compact. 1.07. What is the ratio of the Consumption of fixed capital (as % of GNI) of Romania in 2000 to that in 2005?
Provide a succinct answer. 1.06. What is the ratio of the Consumption of fixed capital (as % of GNI) in Dominican Republic in 2001 to that in 2002?
Give a very brief answer. 0.89. What is the ratio of the Consumption of fixed capital (as % of GNI) in Paraguay in 2001 to that in 2002?
Keep it short and to the point. 1.03. What is the ratio of the Consumption of fixed capital (as % of GNI) in Romania in 2001 to that in 2002?
Your answer should be compact. 0.89. What is the ratio of the Consumption of fixed capital (as % of GNI) in Dominican Republic in 2001 to that in 2003?
Give a very brief answer. 0.7. What is the ratio of the Consumption of fixed capital (as % of GNI) in Paraguay in 2001 to that in 2003?
Offer a very short reply. 1. What is the ratio of the Consumption of fixed capital (as % of GNI) of Romania in 2001 to that in 2003?
Your response must be concise. 0.94. What is the ratio of the Consumption of fixed capital (as % of GNI) in Dominican Republic in 2001 to that in 2004?
Your answer should be very brief. 0.68. What is the ratio of the Consumption of fixed capital (as % of GNI) of Paraguay in 2001 to that in 2004?
Keep it short and to the point. 1.08. What is the ratio of the Consumption of fixed capital (as % of GNI) in Dominican Republic in 2001 to that in 2005?
Your answer should be very brief. 0.77. What is the ratio of the Consumption of fixed capital (as % of GNI) in Paraguay in 2001 to that in 2005?
Offer a very short reply. 1.01. What is the ratio of the Consumption of fixed capital (as % of GNI) of Romania in 2001 to that in 2005?
Keep it short and to the point. 1.05. What is the ratio of the Consumption of fixed capital (as % of GNI) in Dominican Republic in 2002 to that in 2003?
Offer a very short reply. 0.79. What is the ratio of the Consumption of fixed capital (as % of GNI) of Paraguay in 2002 to that in 2003?
Offer a very short reply. 0.97. What is the ratio of the Consumption of fixed capital (as % of GNI) of Romania in 2002 to that in 2003?
Provide a short and direct response. 1.06. What is the ratio of the Consumption of fixed capital (as % of GNI) in Dominican Republic in 2002 to that in 2004?
Your answer should be very brief. 0.77. What is the ratio of the Consumption of fixed capital (as % of GNI) in Paraguay in 2002 to that in 2004?
Offer a terse response. 1.05. What is the ratio of the Consumption of fixed capital (as % of GNI) in Romania in 2002 to that in 2004?
Give a very brief answer. 1.12. What is the ratio of the Consumption of fixed capital (as % of GNI) in Dominican Republic in 2002 to that in 2005?
Provide a succinct answer. 0.87. What is the ratio of the Consumption of fixed capital (as % of GNI) of Paraguay in 2002 to that in 2005?
Offer a terse response. 0.97. What is the ratio of the Consumption of fixed capital (as % of GNI) of Romania in 2002 to that in 2005?
Make the answer very short. 1.19. What is the ratio of the Consumption of fixed capital (as % of GNI) of Dominican Republic in 2003 to that in 2004?
Offer a terse response. 0.97. What is the ratio of the Consumption of fixed capital (as % of GNI) in Paraguay in 2003 to that in 2004?
Offer a terse response. 1.08. What is the ratio of the Consumption of fixed capital (as % of GNI) of Romania in 2003 to that in 2004?
Offer a very short reply. 1.06. What is the ratio of the Consumption of fixed capital (as % of GNI) of Dominican Republic in 2003 to that in 2005?
Your response must be concise. 1.1. What is the ratio of the Consumption of fixed capital (as % of GNI) in Paraguay in 2003 to that in 2005?
Your answer should be compact. 1. What is the ratio of the Consumption of fixed capital (as % of GNI) of Romania in 2003 to that in 2005?
Offer a terse response. 1.12. What is the ratio of the Consumption of fixed capital (as % of GNI) of Dominican Republic in 2004 to that in 2005?
Give a very brief answer. 1.13. What is the ratio of the Consumption of fixed capital (as % of GNI) in Paraguay in 2004 to that in 2005?
Provide a short and direct response. 0.93. What is the ratio of the Consumption of fixed capital (as % of GNI) of Romania in 2004 to that in 2005?
Your answer should be very brief. 1.06. What is the difference between the highest and the second highest Consumption of fixed capital (as % of GNI) in Dominican Republic?
Make the answer very short. 0.17. What is the difference between the highest and the second highest Consumption of fixed capital (as % of GNI) in Paraguay?
Give a very brief answer. 0.73. What is the difference between the highest and the second highest Consumption of fixed capital (as % of GNI) of Romania?
Keep it short and to the point. 0.69. What is the difference between the highest and the lowest Consumption of fixed capital (as % of GNI) of Dominican Republic?
Your answer should be very brief. 3.12. What is the difference between the highest and the lowest Consumption of fixed capital (as % of GNI) of Paraguay?
Provide a short and direct response. 2.41. What is the difference between the highest and the lowest Consumption of fixed capital (as % of GNI) in Romania?
Give a very brief answer. 3.56. 